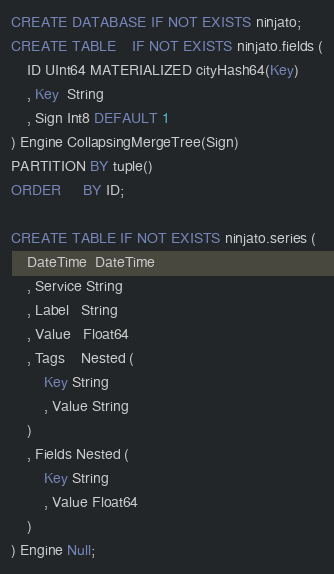Convert code to text. <code><loc_0><loc_0><loc_500><loc_500><_SQL_>CREATE DATABASE IF NOT EXISTS ninjato;
CREATE TABLE    IF NOT EXISTS ninjato.fields (
    ID UInt64 MATERIALIZED cityHash64(Key)
    , Key  String
    , Sign Int8 DEFAULT 1
) Engine CollapsingMergeTree(Sign)
PARTITION BY tuple()
ORDER     BY ID;

CREATE TABLE IF NOT EXISTS ninjato.series (
    DateTime  DateTime
    , Service String
    , Label   String
    , Value   Float64
    , Tags    Nested (
        Key String
        , Value String
    )
    , Fields Nested (
        Key String 
        , Value Float64
    )
) Engine Null;</code> 